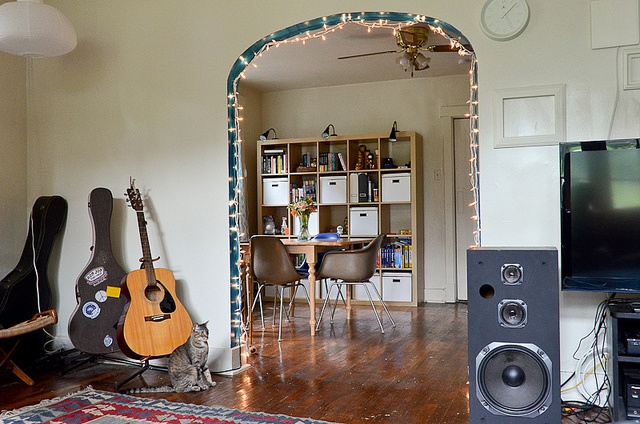Describe the objects in this image and their specific colors. I can see tv in gray, black, and purple tones, book in gray, black, darkgray, and maroon tones, chair in gray, darkgray, and black tones, chair in gray, maroon, and black tones, and dining table in gray, tan, maroon, and black tones in this image. 